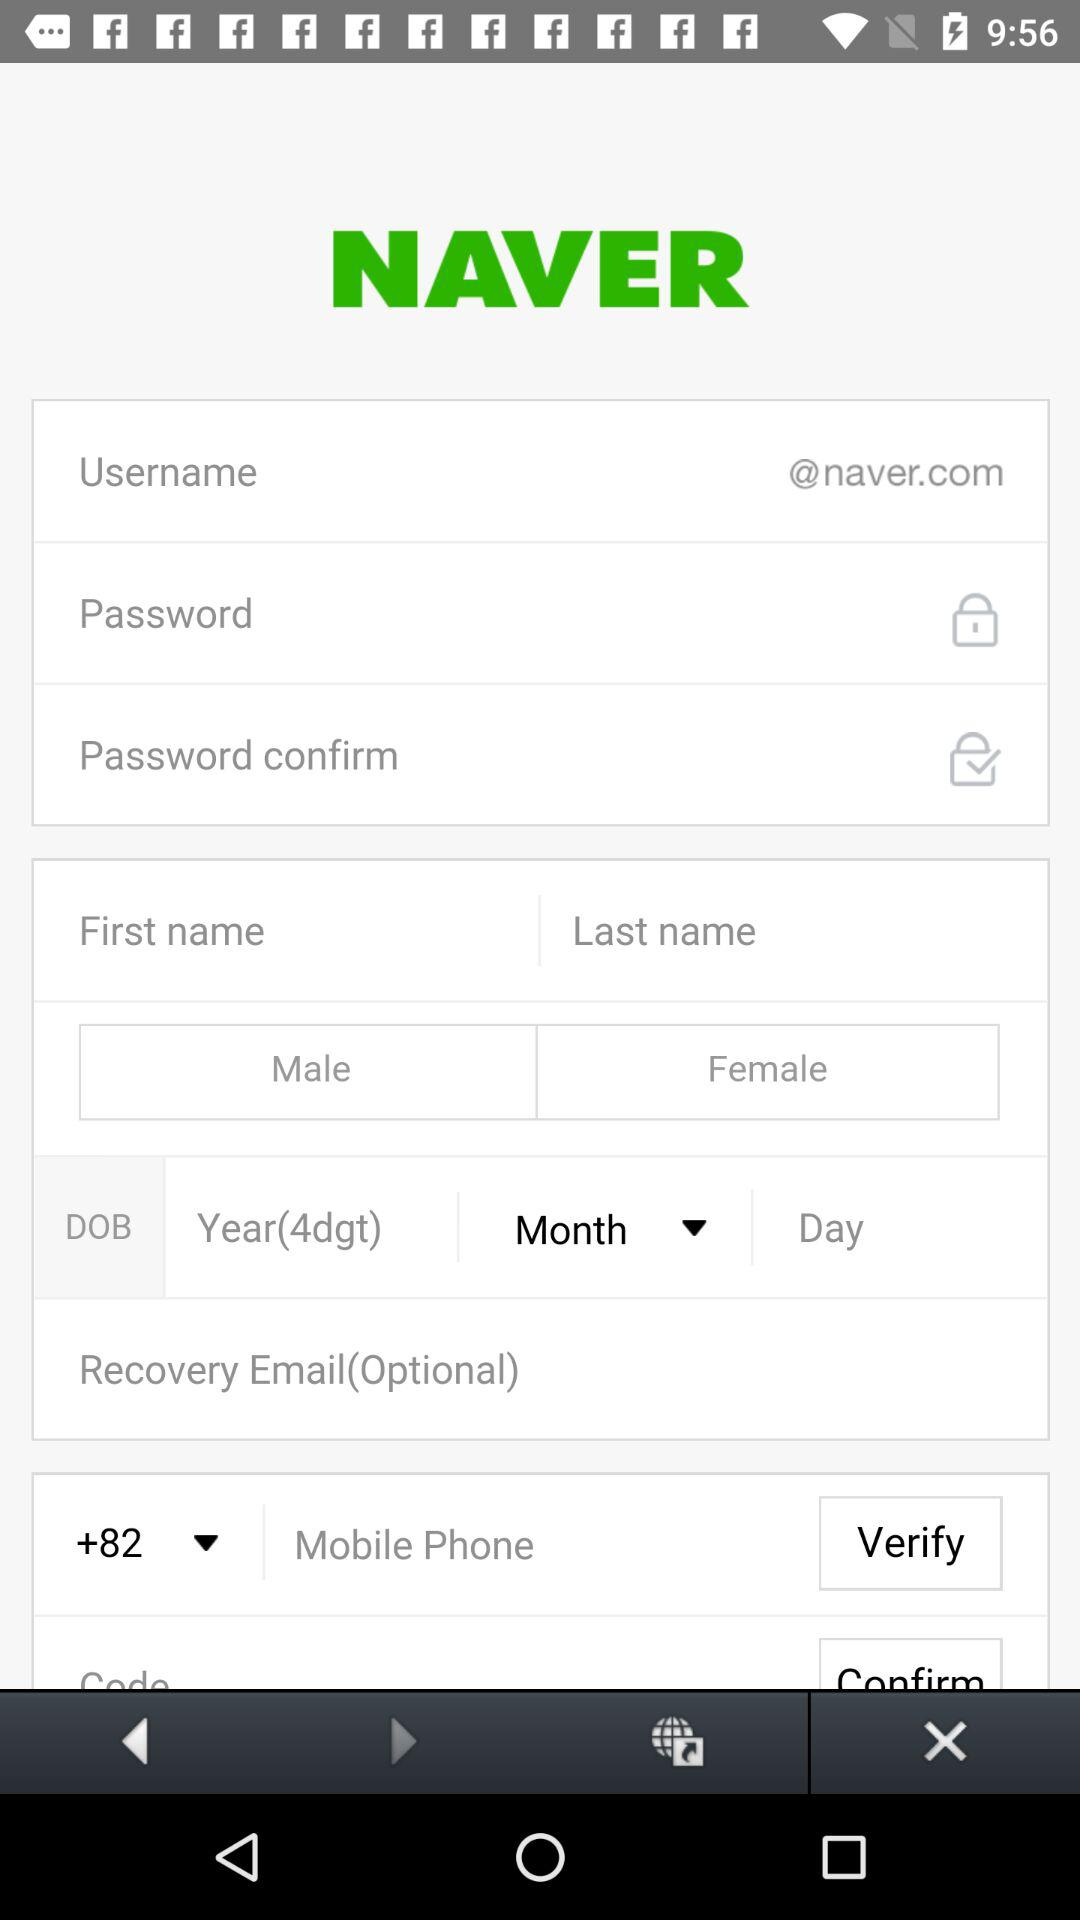What is the application name? The application name is "NAVER". 